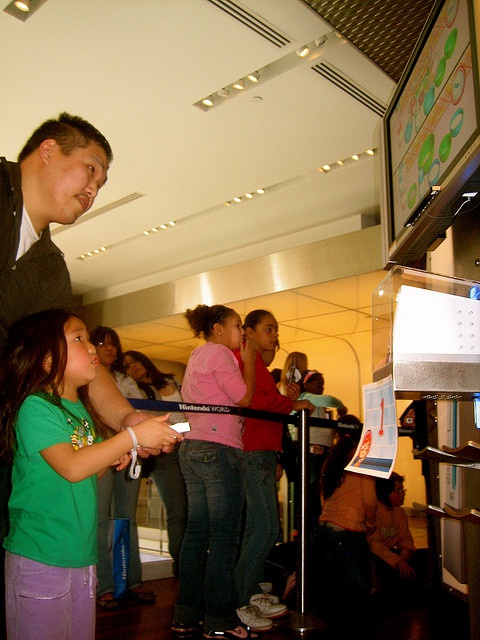Describe the objects in this image and their specific colors. I can see people in tan, green, black, purple, and darkgreen tones, people in tan, black, brown, salmon, and maroon tones, people in tan, black, red, and maroon tones, tv in tan and olive tones, and people in tan, black, maroon, and gray tones in this image. 